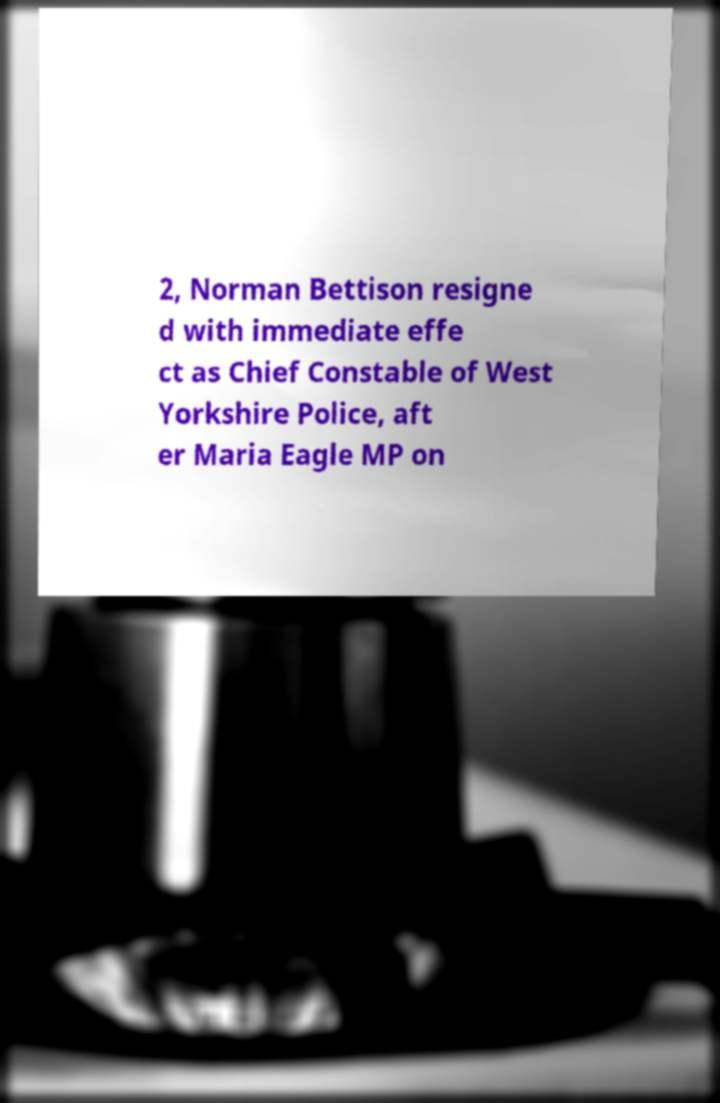For documentation purposes, I need the text within this image transcribed. Could you provide that? 2, Norman Bettison resigne d with immediate effe ct as Chief Constable of West Yorkshire Police, aft er Maria Eagle MP on 